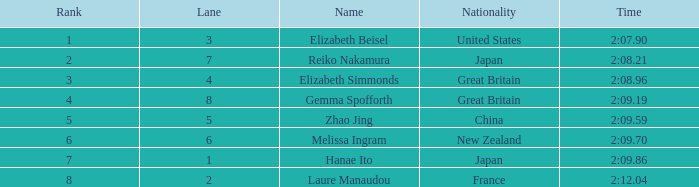What is laure manaudou's top position? 8.0. 